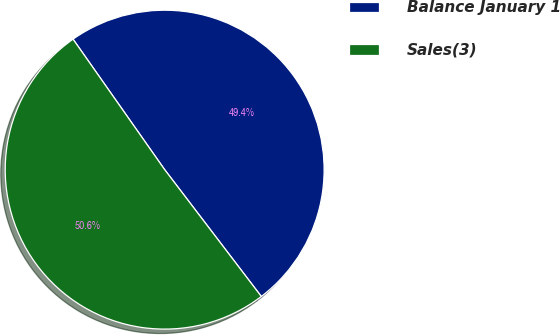Convert chart to OTSL. <chart><loc_0><loc_0><loc_500><loc_500><pie_chart><fcel>Balance January 1<fcel>Sales(3)<nl><fcel>49.38%<fcel>50.62%<nl></chart> 